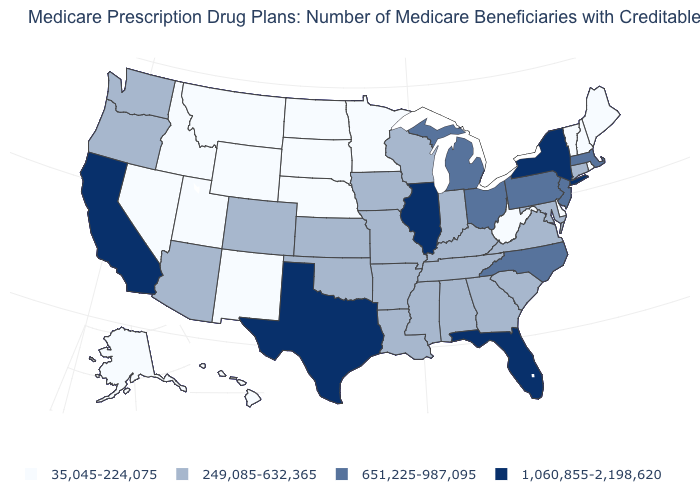Which states hav the highest value in the Northeast?
Write a very short answer. New York. What is the value of Massachusetts?
Write a very short answer. 651,225-987,095. What is the value of New York?
Short answer required. 1,060,855-2,198,620. What is the value of South Carolina?
Answer briefly. 249,085-632,365. What is the value of Alabama?
Write a very short answer. 249,085-632,365. What is the value of Louisiana?
Short answer required. 249,085-632,365. What is the highest value in the USA?
Keep it brief. 1,060,855-2,198,620. Which states have the lowest value in the USA?
Be succinct. Alaska, Delaware, Hawaii, Idaho, Maine, Minnesota, Montana, Nebraska, Nevada, New Hampshire, New Mexico, North Dakota, Rhode Island, South Dakota, Utah, Vermont, West Virginia, Wyoming. Does New York have the lowest value in the Northeast?
Concise answer only. No. What is the value of Kansas?
Keep it brief. 249,085-632,365. Does the first symbol in the legend represent the smallest category?
Be succinct. Yes. Does the first symbol in the legend represent the smallest category?
Quick response, please. Yes. Does Maine have the lowest value in the Northeast?
Concise answer only. Yes. What is the value of Massachusetts?
Concise answer only. 651,225-987,095. Name the states that have a value in the range 651,225-987,095?
Short answer required. Massachusetts, Michigan, New Jersey, North Carolina, Ohio, Pennsylvania. 